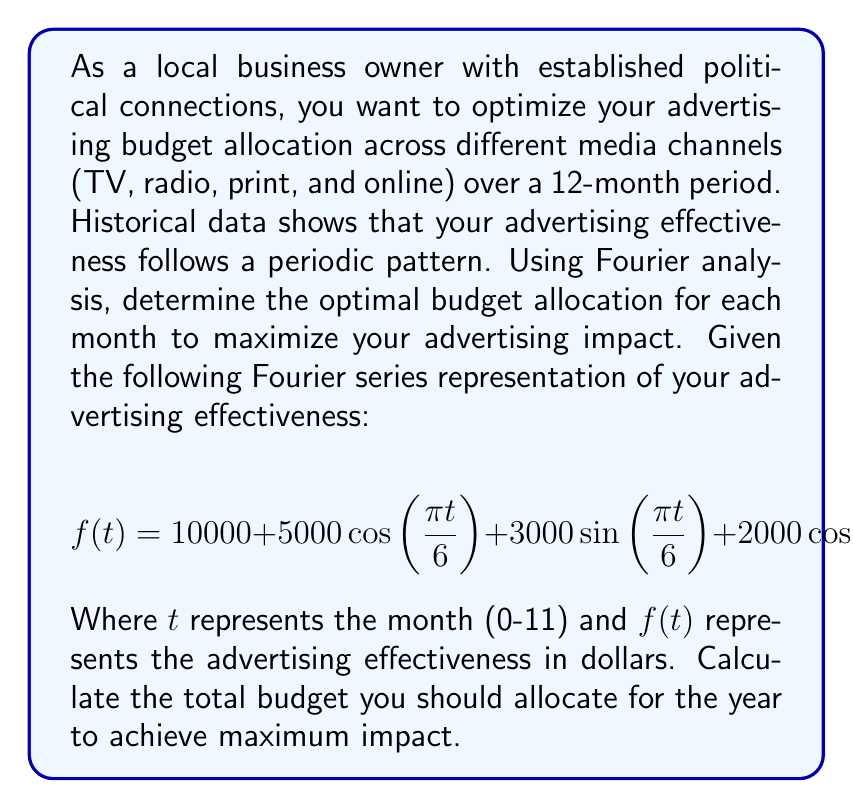Give your solution to this math problem. To solve this problem, we need to follow these steps:

1) The Fourier series given represents the advertising effectiveness for each month. To find the optimal budget allocation, we need to calculate $f(t)$ for each month $t$ from 0 to 11.

2) Let's calculate $f(t)$ for each month:

   For $t = 0$:
   $$f(0) = 10000 + 5000\cos(0) + 3000\sin(0) + 2000\cos(0) + 1000\sin(0) = 17000$$

   For $t = 1$:
   $$f(1) = 10000 + 5000\cos(\frac{\pi}{6}) + 3000\sin(\frac{\pi}{6}) + 2000\cos(\frac{\pi}{3}) + 1000\sin(\frac{\pi}{3}) \approx 16933.01$$

   We continue this process for $t = 2$ to $t = 11$.

3) After calculating for all months, we get:

   $f(0) = 17000.00$
   $f(1) = 16933.01$
   $f(2) = 16732.05$
   $f(3) = 16397.11$
   $f(4) = 15928.20$
   $f(5) = 15325.00$
   $f(6) = 14600.00$
   $f(7) = 13774.99$
   $f(8) = 12871.79$
   $f(9) = 11922.88$
   $f(10) = 10967.94$
   $f(11) = 10066.98$

4) To maximize the advertising impact, we should allocate the budget proportionally to these effectiveness values.

5) The total budget for the year would be the sum of all these monthly values:

   $$\text{Total Budget} = \sum_{t=0}^{11} f(t) = 171519.95$$

Therefore, the optimal total budget allocation for the year is approximately $171,519.95.
Answer: The optimal total advertising budget allocation for the year to maximize impact is $171,519.95. 